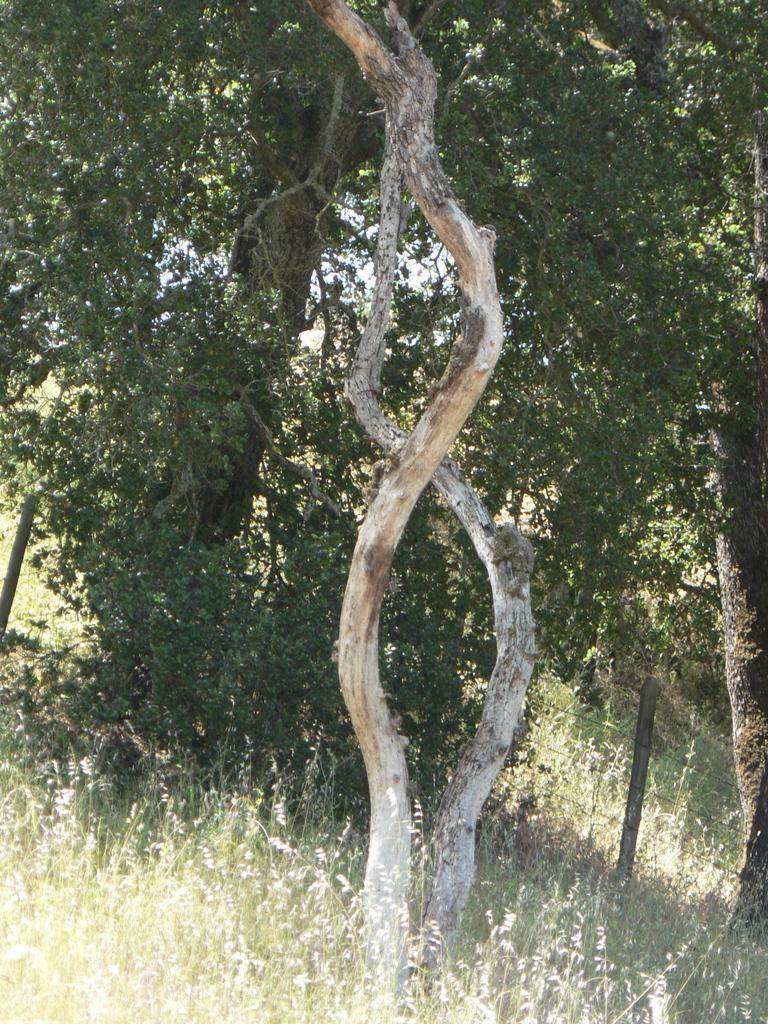Could you give a brief overview of what you see in this image? In the center of the image there is a fencing. In the background of the image trees are present. At the top of the image grass is there. At the bottom of the image sky is present. 